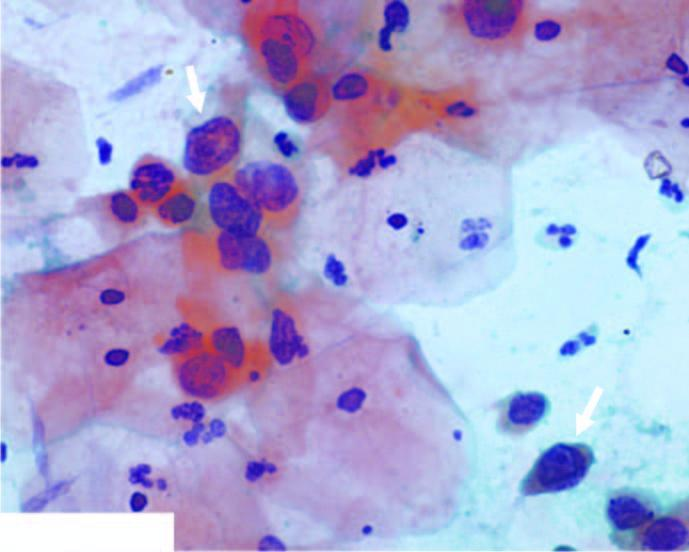did scanty cytoplasm and markedly hyperchromatic nuclei have irregular nuclear outlines?
Answer the question using a single word or phrase. Yes 